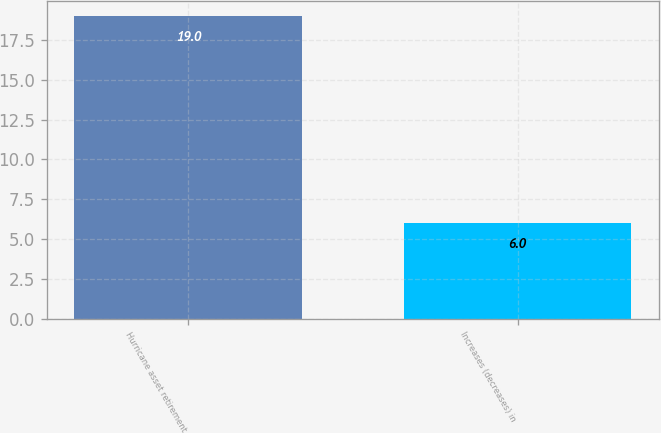Convert chart to OTSL. <chart><loc_0><loc_0><loc_500><loc_500><bar_chart><fcel>Hurricane asset retirement<fcel>Increases (decreases) in<nl><fcel>19<fcel>6<nl></chart> 